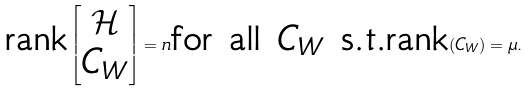<formula> <loc_0><loc_0><loc_500><loc_500>\text {rank} \begin{bmatrix} \mathcal { H } \\ C _ { W } \\ \end{bmatrix} = n \text {for all  $C_{W}$ s.t.} \text {rank} ( C _ { W } ) = \mu .</formula> 